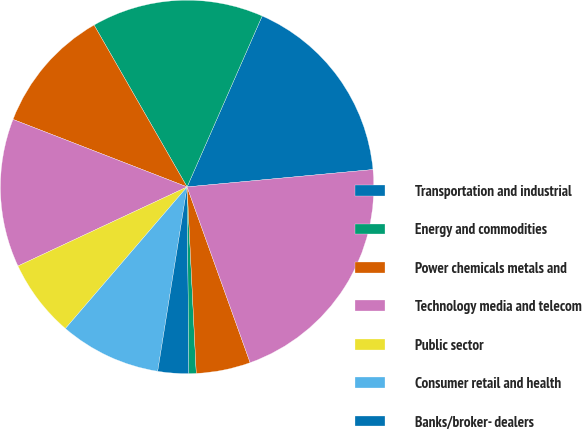<chart> <loc_0><loc_0><loc_500><loc_500><pie_chart><fcel>Transportation and industrial<fcel>Energy and commodities<fcel>Power chemicals metals and<fcel>Technology media and telecom<fcel>Public sector<fcel>Consumer retail and health<fcel>Banks/broker- dealers<fcel>Insurance and special purpose<fcel>Other industries<fcel>Total<nl><fcel>16.93%<fcel>14.89%<fcel>10.81%<fcel>12.85%<fcel>6.74%<fcel>8.78%<fcel>2.67%<fcel>0.63%<fcel>4.7%<fcel>21.0%<nl></chart> 